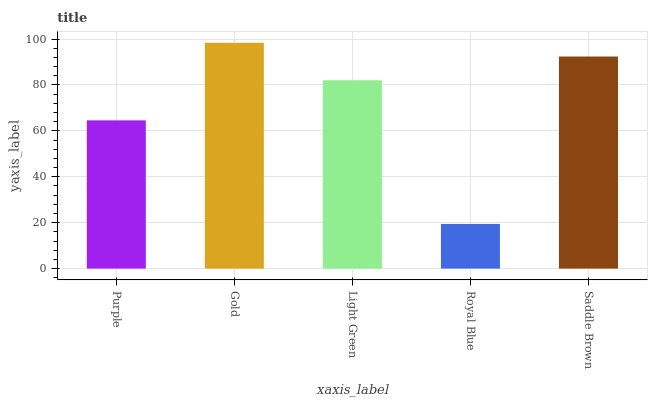Is Royal Blue the minimum?
Answer yes or no. Yes. Is Gold the maximum?
Answer yes or no. Yes. Is Light Green the minimum?
Answer yes or no. No. Is Light Green the maximum?
Answer yes or no. No. Is Gold greater than Light Green?
Answer yes or no. Yes. Is Light Green less than Gold?
Answer yes or no. Yes. Is Light Green greater than Gold?
Answer yes or no. No. Is Gold less than Light Green?
Answer yes or no. No. Is Light Green the high median?
Answer yes or no. Yes. Is Light Green the low median?
Answer yes or no. Yes. Is Royal Blue the high median?
Answer yes or no. No. Is Purple the low median?
Answer yes or no. No. 